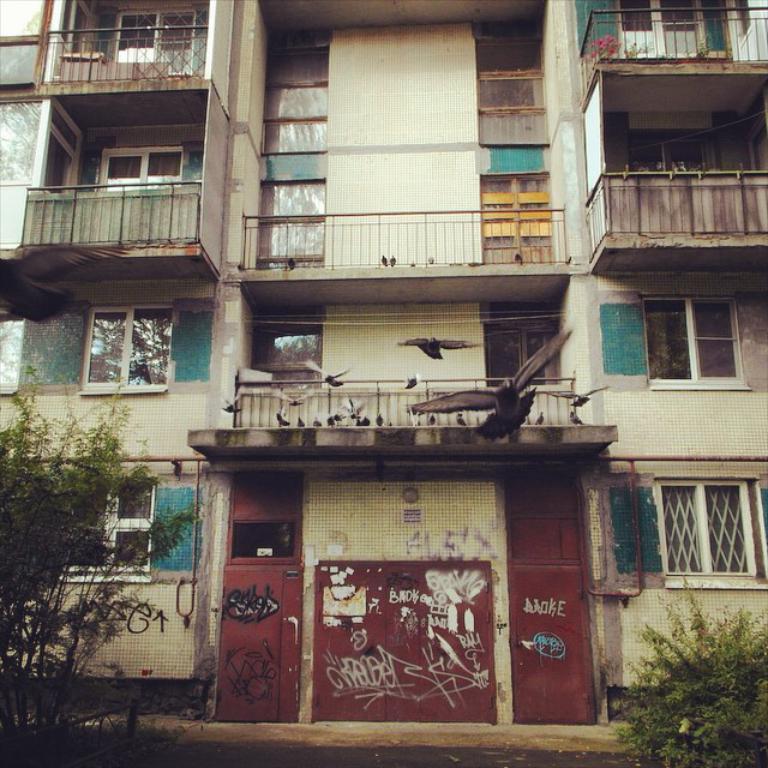Describe this image in one or two sentences. In this image I can see a building and number of windows. I can also see railings, birds and in the front of the building I can see two plants. On the bottom side of this image I can see something is written on the building's wall. 